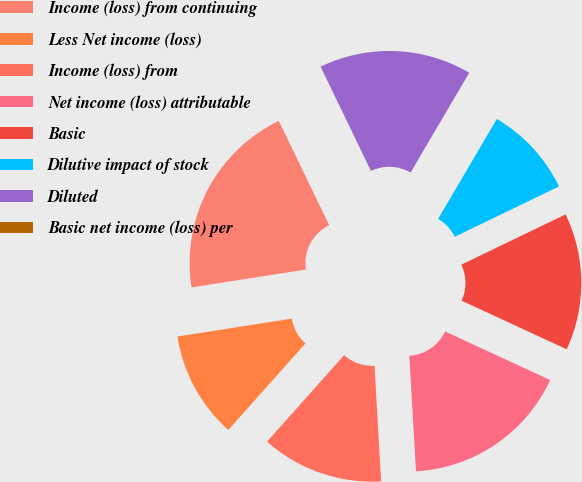Convert chart. <chart><loc_0><loc_0><loc_500><loc_500><pie_chart><fcel>Income (loss) from continuing<fcel>Less Net income (loss)<fcel>Income (loss) from<fcel>Net income (loss) attributable<fcel>Basic<fcel>Dilutive impact of stock<fcel>Diluted<fcel>Basic net income (loss) per<nl><fcel>20.31%<fcel>10.94%<fcel>12.5%<fcel>17.19%<fcel>14.06%<fcel>9.38%<fcel>15.62%<fcel>0.0%<nl></chart> 